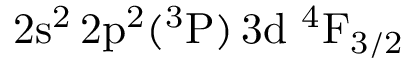<formula> <loc_0><loc_0><loc_500><loc_500>2 s ^ { 2 } \, 2 p ^ { 2 } ( ^ { 3 } P ) \, 3 d ^ { 4 } F _ { 3 / 2 }</formula> 